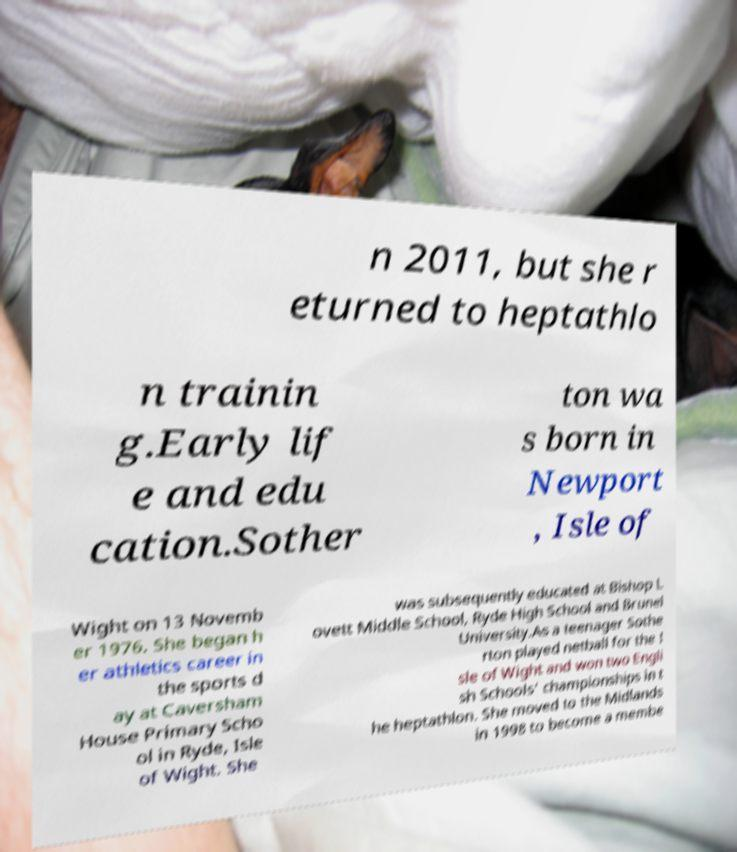There's text embedded in this image that I need extracted. Can you transcribe it verbatim? n 2011, but she r eturned to heptathlo n trainin g.Early lif e and edu cation.Sother ton wa s born in Newport , Isle of Wight on 13 Novemb er 1976. She began h er athletics career in the sports d ay at Caversham House Primary Scho ol in Ryde, Isle of Wight. She was subsequently educated at Bishop L ovett Middle School, Ryde High School and Brunel University.As a teenager Sothe rton played netball for the I sle of Wight and won two Engli sh Schools' championships in t he heptathlon. She moved to the Midlands in 1998 to become a membe 